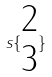<formula> <loc_0><loc_0><loc_500><loc_500>s \{ \begin{matrix} 2 \\ 3 \end{matrix} \}</formula> 